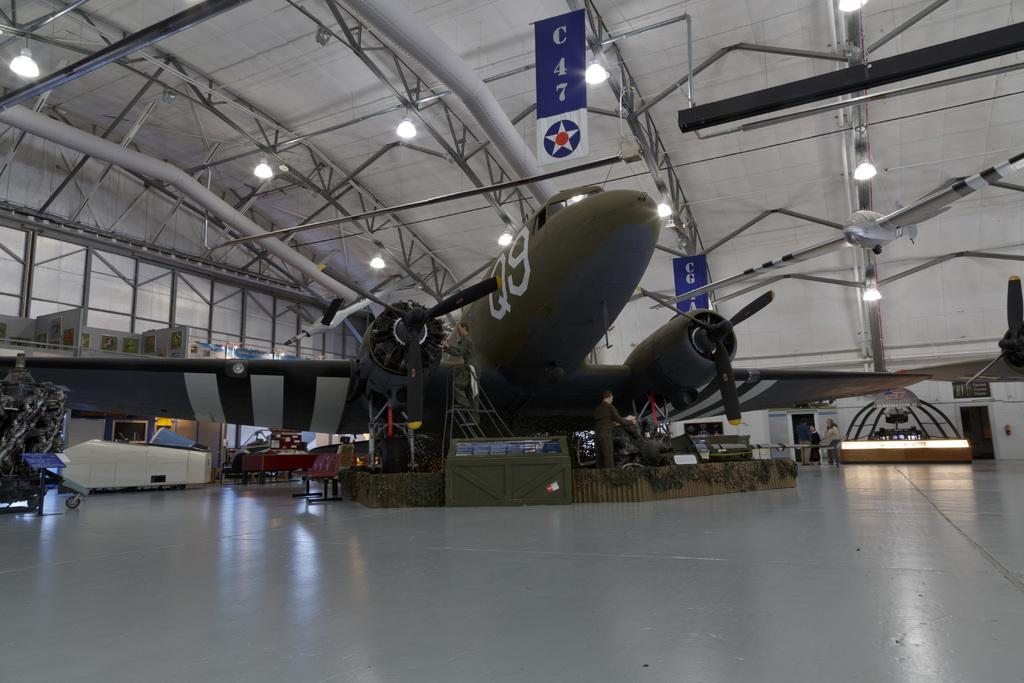<image>
Create a compact narrative representing the image presented. Airplane hangar that is displaying a Q9 military collection. 